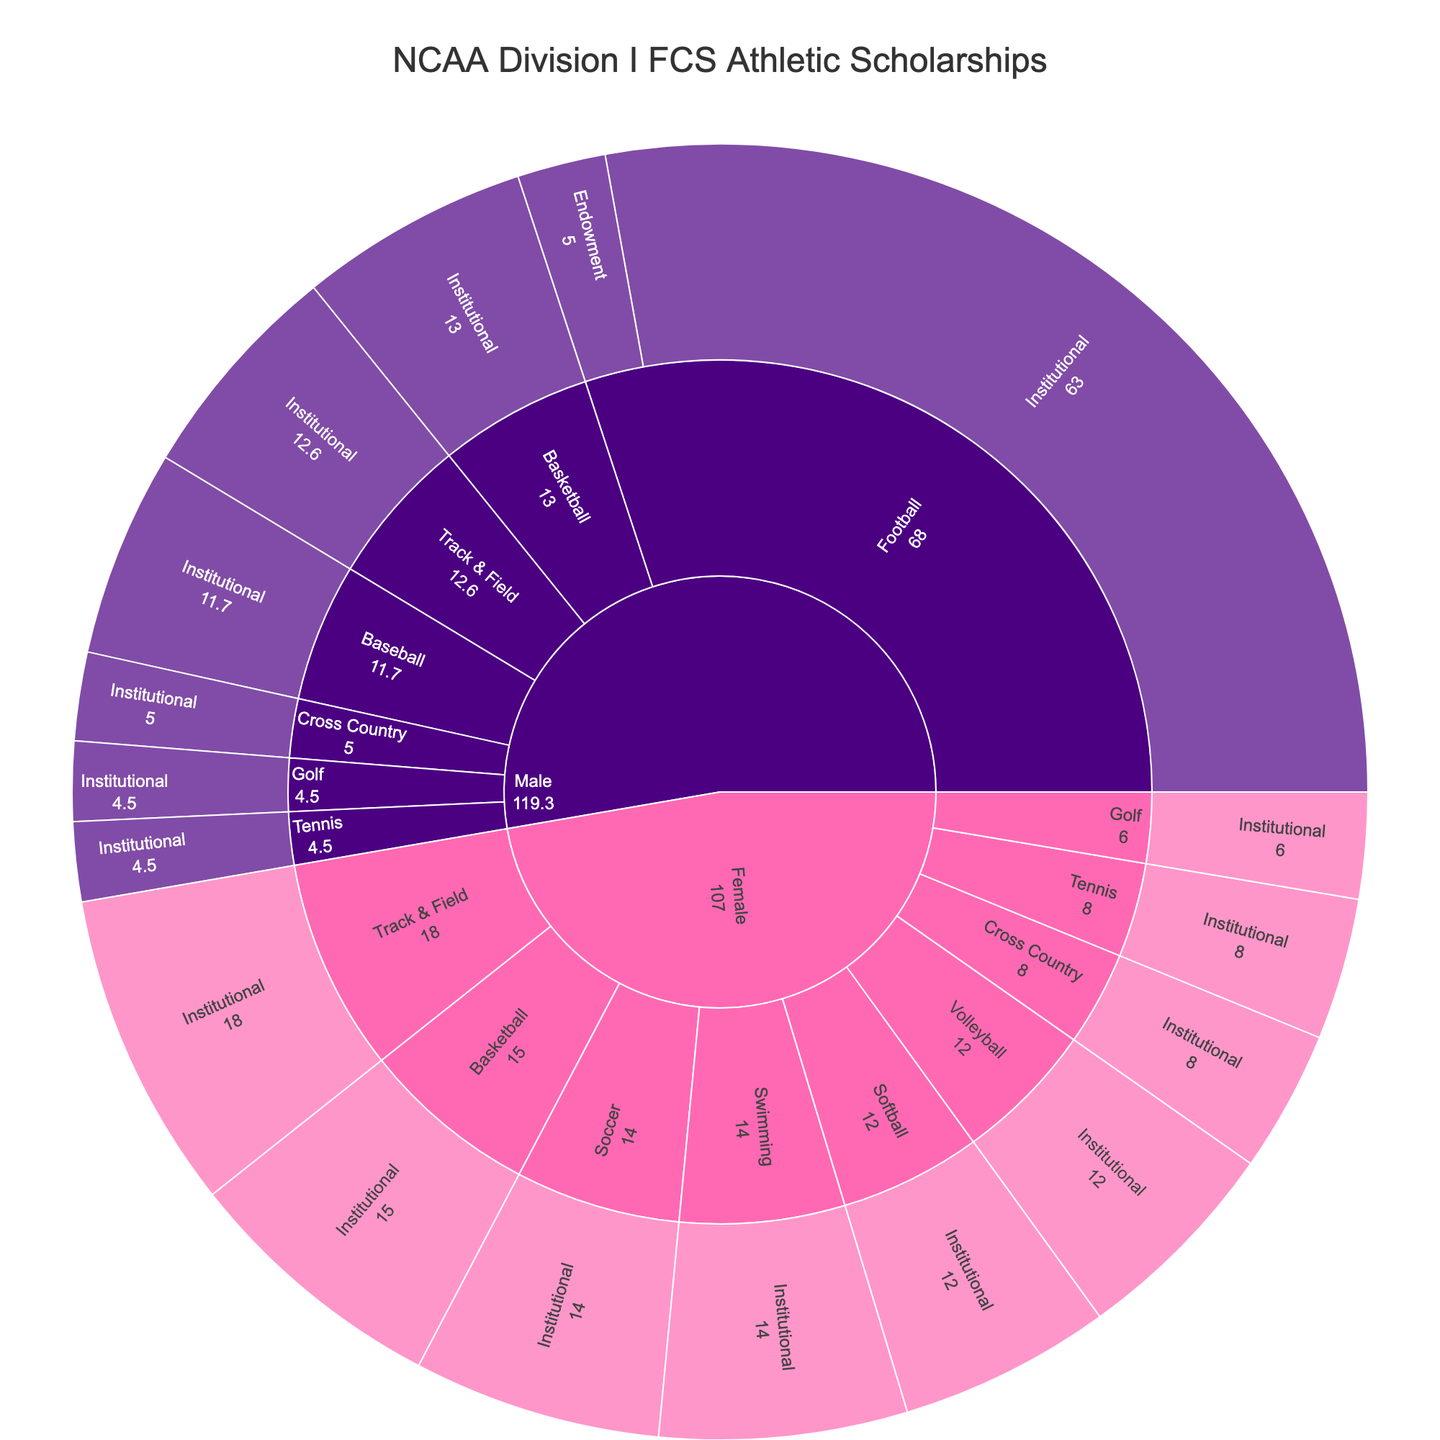what is the total number of scholarships for Male athletes? The figure shows scholarships allocation by sport, gender, and funding source. Sum the scholarships for all the Male categories: Football (63 + 5), Basketball (13), Track & Field (12.6), Baseball (11.7), Tennis (4.5), Golf (4.5), Cross Country (5). Therefore, 63 + 5 + 13 + 12.6 + 11.7 + 4.5 + 4.5 + 5 = 119.3
Answer: 119.3 How many scholarships are funded by Endowment for Football? Find the segment labeled “Football” under "Male" and "Endowment" category. The figure indicates this number directly.
Answer: 5 Which sport has the highest number of scholarships among Female athletes? Look at the segments under "Female" and compare the scholarships across different sports: Basketball (15), Track & Field (18), Softball (12), Volleyball (12), Tennis (8), Soccer (14), Golf (6), Cross Country (8), Swimming (14). The sport with the highest number is Track & Field with 18 scholarships.
Answer: Track & Field Compare the total number of scholarships given to Female athletes versus Male athletes. Which gender has more scholarships? Sum scholarships for all Female athletes: Basketball (15), Track & Field (18), Softball (12), Volleyball (12), Tennis (8), Soccer (14), Golf (6), Cross Country (8), Swimming (14). Total for females: 15 + 18 + 12 + 12 + 8 + 14 + 6 + 8 + 14 = 107. For males: Football (63 + 5), Basketball (13), Track & Field (12.6), Baseball (11.7), Tennis (4.5), Golf (4.5), Cross Country (5). Total for males: 63 + 5 + 13 + 12.6 + 11.7 + 4.5 + 4.5 + 5 = 119.3. Male athletes have more scholarships, 119.3 compared to 107.
Answer: Male What is the ratio of institutional scholarships to endowment scholarships for Male football? From the figure, Male Football has 63 institutional and 5 endowment scholarships. The ratio is 63:5.
Answer: 63:5 How many scholarships are allocated for sports other than Football? Subtract the total scholarships for Football from the overall scholarships. Football (Male) has 63 + 5 = 68 scholarships. Total scholarships: 119.3 (Male) + 107 (Female) = 226.3. Non-Football scholarships: 226.3 - 68 = 158.3.
Answer: 158.3 What sport has the second highest number of scholarships for Male athletes funded institutionally? Look at institutional scholarships for male athletes. Football has the highest (63), followed by Basketball (13), then Track & Field (12.6). The second highest is Basketball with 13 scholarships.
Answer: Basketball How many more scholarships does Female Track & Field have compared to Male Track & Field? Female Track & Field has 18 scholarships and Male Track & Field has 12.6. The difference is 18 - 12.6 = 5.4.
Answer: 5.4 What proportion of total Female scholarships does Volleyball represent? Volleyball has 12 scholarships out of the total of 107 for Female athletes. The proportion is calculated as (12 / 107) = 0.1121, approximately 11.21%.
Answer: 11.21% 